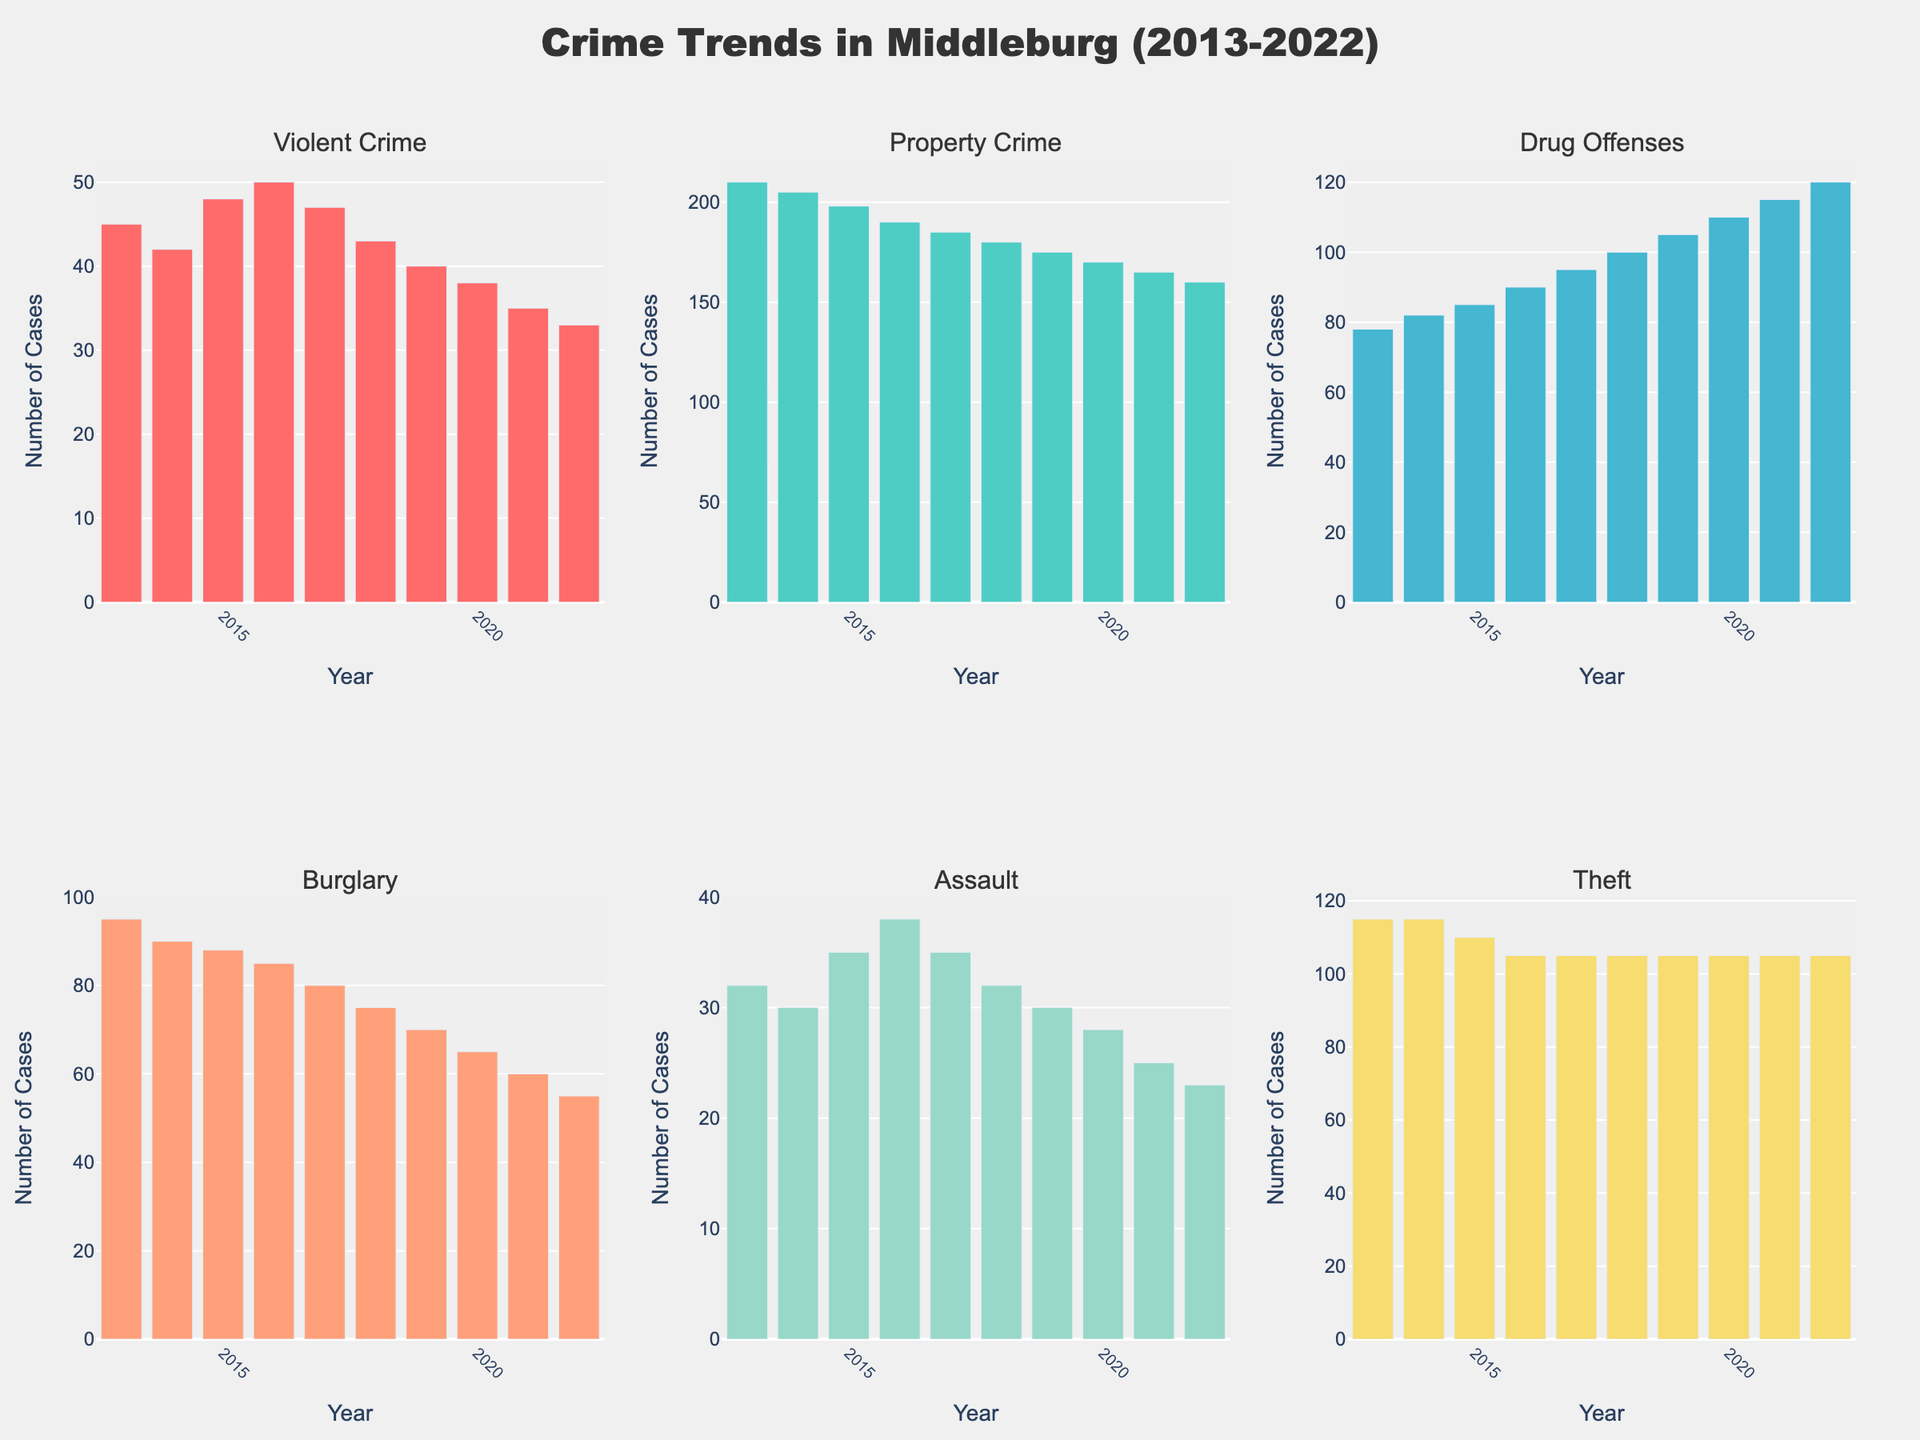How has the number of violent crimes changed from 2013 to 2022? From the bar representing violent crimes, the height of the bar in 2013 shows 45 cases and it gradually decreases each year to 33 cases in 2022.
Answer: Decreased Comparing the peak year for drug offenses to the peak year for burglary, which was higher? The bar for drug offenses is highest in 2022 with 120 cases, whereas the highest bar for burglary is in 2013 with 95 cases. Hence, the peak year for drug offenses has a higher number.
Answer: Drug offenses in 2022 Which type of crime had the most significant decrease from 2013 to 2022? Looking at the change in bar height, violent crime decreased from 45 to 33 cases, property crime decreased from 210 to 160 cases, drug offenses increased, burglary decreased from 95 to 55 cases, assault decreased from 32 to 23 cases, and theft remained constant. Property crime dropped the most significantly by 50 cases.
Answer: Property crime Calculate the average number of drug offenses from 2013 to 2022. Sum the drug offenses from each year (78 + 82 + 85 + 90 + 95 + 100 + 105 + 110 + 115 + 120) = 980 and then divide by the number of years, which is 10. 980/10 = 98
Answer: 98 Did any type of crime remain constant over the years? Observing the bars over the years, theft has the same bar height from 2015 to 2022 at 105 cases.
Answer: Theft What year did the lowest number of assaults occur? The shortest bar in the assault subplot corresponds to the year 2022 with 23 assault cases.
Answer: 2022 What type of crime had the most consistent decrease over the decade? By examining the bar charts, violent crime consistently decreased every year from 45 in 2013 to 33 in 2022 without any increase.
Answer: Violent crime 